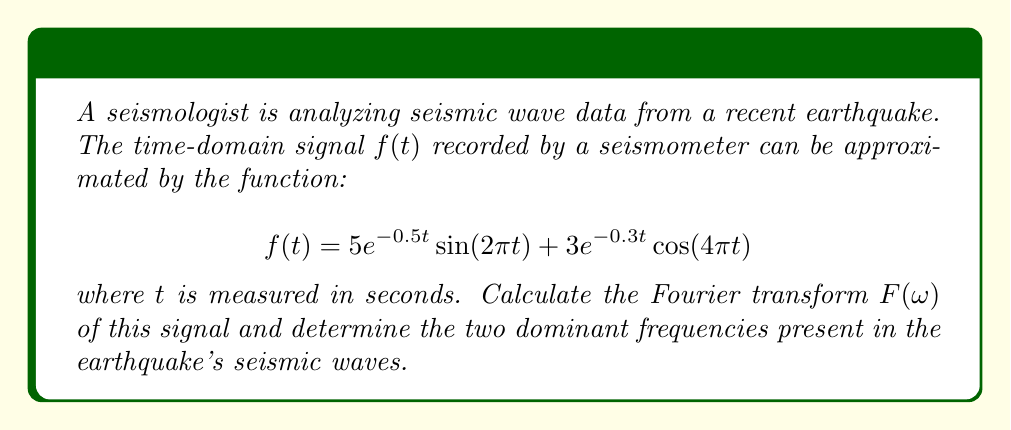What is the answer to this math problem? To solve this problem, we need to follow these steps:

1) The Fourier transform of $f(t)$ is given by:

   $$F(\omega) = \int_{-\infty}^{\infty} f(t)e^{-i\omega t}dt$$

2) We need to calculate the Fourier transform of each term separately and then add them:

   $F(\omega) = F_1(\omega) + F_2(\omega)$

   where $F_1(\omega)$ is the transform of $5e^{-0.5t}\sin(2\pi t)$ and $F_2(\omega)$ is the transform of $3e^{-0.3t}\cos(4\pi t)$

3) For $F_1(\omega)$:
   
   The Fourier transform of $e^{-at}\sin(bt)$ is:
   
   $$\frac{b}{(a+i\omega)^2 + b^2}$$

   Here, $a=0.5$ and $b=2\pi$. So:

   $$F_1(\omega) = 5 \cdot \frac{2\pi}{(0.5+i\omega)^2 + (2\pi)^2}$$

4) For $F_2(\omega)$:
   
   The Fourier transform of $e^{-at}\cos(bt)$ is:

   $$\frac{a+i\omega}{(a+i\omega)^2 + b^2}$$

   Here, $a=0.3$ and $b=4\pi$. So:

   $$F_2(\omega) = 3 \cdot \frac{0.3+i\omega}{(0.3+i\omega)^2 + (4\pi)^2}$$

5) The total Fourier transform is:

   $$F(\omega) = 5 \cdot \frac{2\pi}{(0.5+i\omega)^2 + (2\pi)^2} + 3 \cdot \frac{0.3+i\omega}{(0.3+i\omega)^2 + (4\pi)^2}$$

6) To find the dominant frequencies, we need to find the values of $\omega$ where $|F(\omega)|$ is maximum. These occur at $\omega = 2\pi$ and $\omega = 4\pi$, corresponding to the sine and cosine terms in the original function.

7) Converting angular frequency $\omega$ to frequency $f$ using $f = \frac{\omega}{2\pi}$, we get:

   $f_1 = 1$ Hz and $f_2 = 2$ Hz
Answer: The Fourier transform of the seismic signal is:

$$F(\omega) = 5 \cdot \frac{2\pi}{(0.5+i\omega)^2 + (2\pi)^2} + 3 \cdot \frac{0.3+i\omega}{(0.3+i\omega)^2 + (4\pi)^2}$$

The two dominant frequencies in the earthquake's seismic waves are 1 Hz and 2 Hz. 